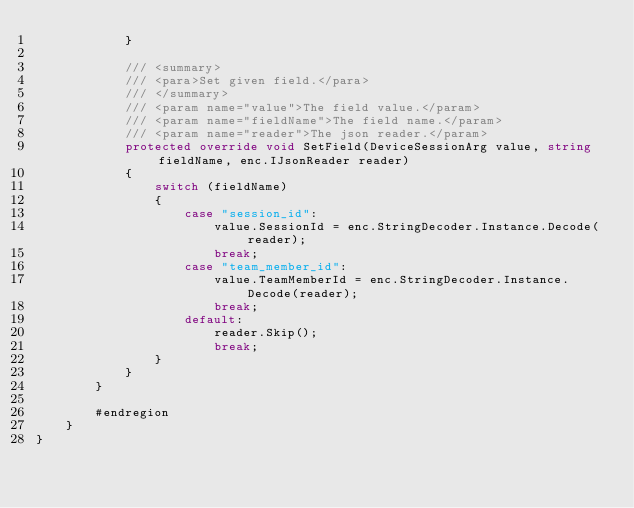<code> <loc_0><loc_0><loc_500><loc_500><_C#_>            }

            /// <summary>
            /// <para>Set given field.</para>
            /// </summary>
            /// <param name="value">The field value.</param>
            /// <param name="fieldName">The field name.</param>
            /// <param name="reader">The json reader.</param>
            protected override void SetField(DeviceSessionArg value, string fieldName, enc.IJsonReader reader)
            {
                switch (fieldName)
                {
                    case "session_id":
                        value.SessionId = enc.StringDecoder.Instance.Decode(reader);
                        break;
                    case "team_member_id":
                        value.TeamMemberId = enc.StringDecoder.Instance.Decode(reader);
                        break;
                    default:
                        reader.Skip();
                        break;
                }
            }
        }

        #endregion
    }
}
</code> 